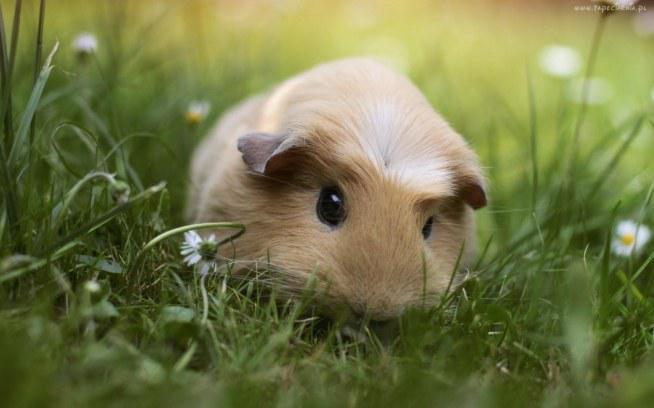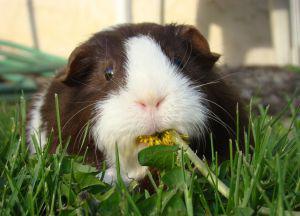The first image is the image on the left, the second image is the image on the right. Given the left and right images, does the statement "One of the images features a guinea pig munching on foliage." hold true? Answer yes or no. Yes. The first image is the image on the left, the second image is the image on the right. Given the left and right images, does the statement "The left image shows a guinea pig standing on grass near tiny white flowers, and the right image shows one guinea pig with something yellowish in its mouth." hold true? Answer yes or no. Yes. 